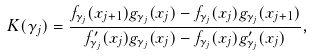Convert formula to latex. <formula><loc_0><loc_0><loc_500><loc_500>K ( \gamma _ { j } ) = \frac { f _ { \gamma _ { j } } ( x _ { j + 1 } ) g _ { \gamma _ { j } } ( x _ { j } ) - f _ { \gamma _ { j } } ( x _ { j } ) g _ { \gamma _ { j } } ( x _ { j + 1 } ) } { f ^ { \prime } _ { \gamma _ { j } } ( x _ { j } ) g _ { \gamma _ { j } } ( x _ { j } ) - f _ { \gamma _ { j } } ( x _ { j } ) g ^ { \prime } _ { \gamma _ { j } } ( x _ { j } ) } ,</formula> 